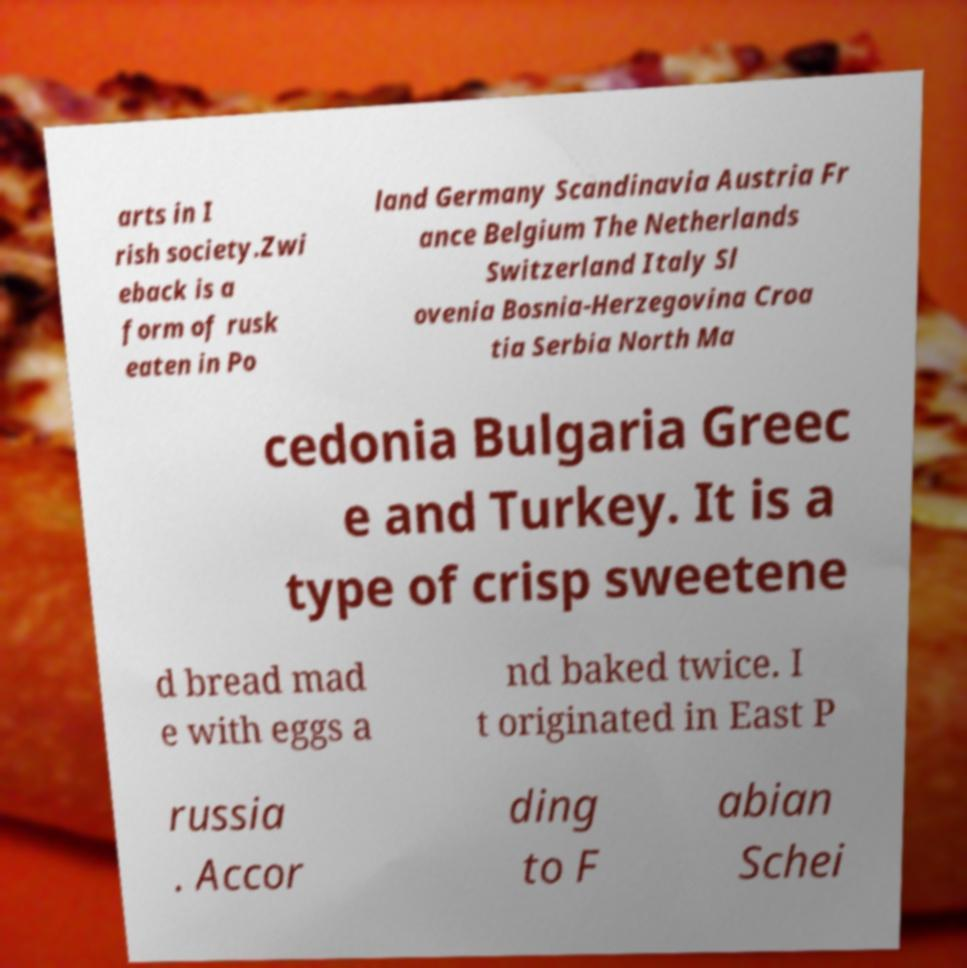Could you extract and type out the text from this image? arts in I rish society.Zwi eback is a form of rusk eaten in Po land Germany Scandinavia Austria Fr ance Belgium The Netherlands Switzerland Italy Sl ovenia Bosnia-Herzegovina Croa tia Serbia North Ma cedonia Bulgaria Greec e and Turkey. It is a type of crisp sweetene d bread mad e with eggs a nd baked twice. I t originated in East P russia . Accor ding to F abian Schei 